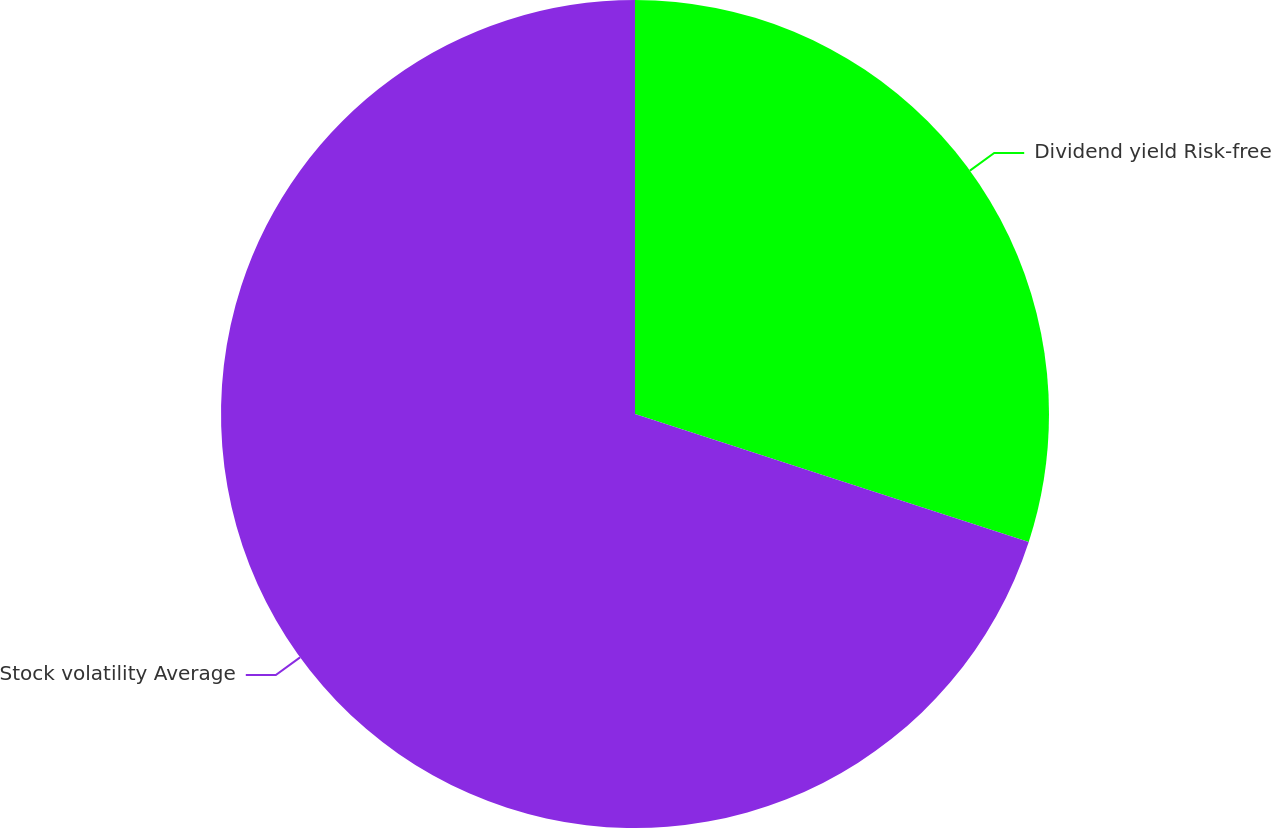<chart> <loc_0><loc_0><loc_500><loc_500><pie_chart><fcel>Dividend yield Risk-free<fcel>Stock volatility Average<nl><fcel>30.0%<fcel>70.0%<nl></chart> 